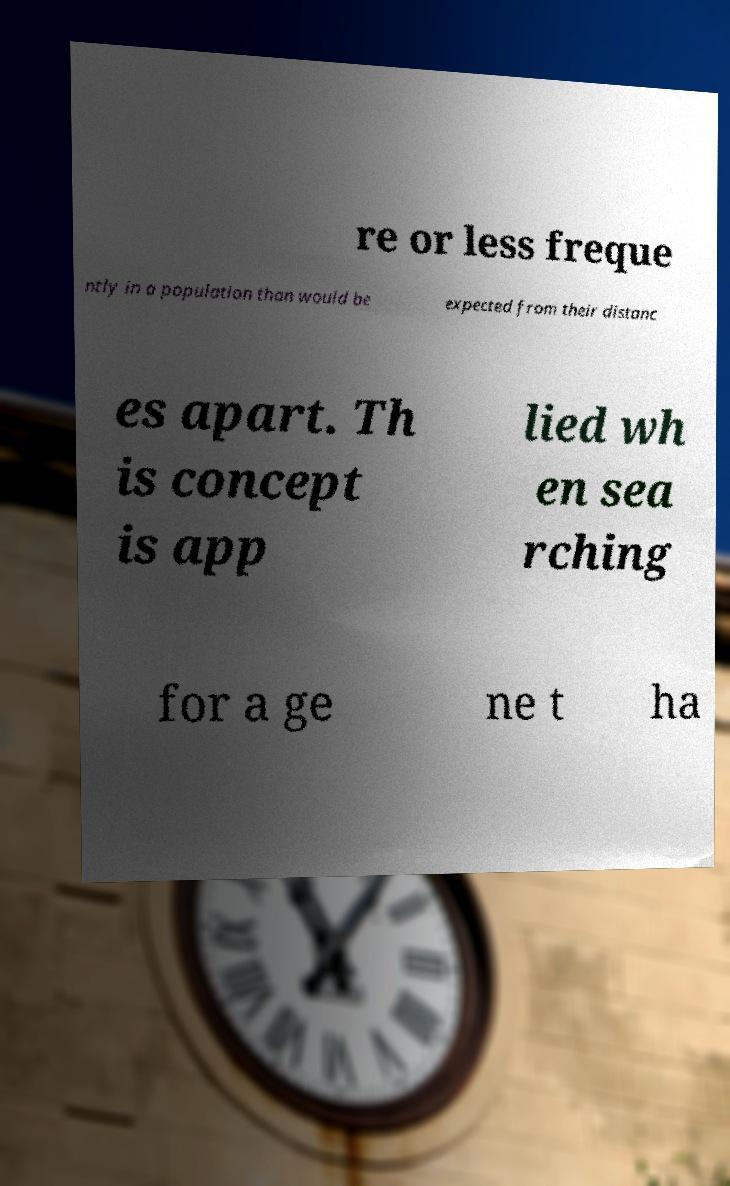Could you extract and type out the text from this image? re or less freque ntly in a population than would be expected from their distanc es apart. Th is concept is app lied wh en sea rching for a ge ne t ha 